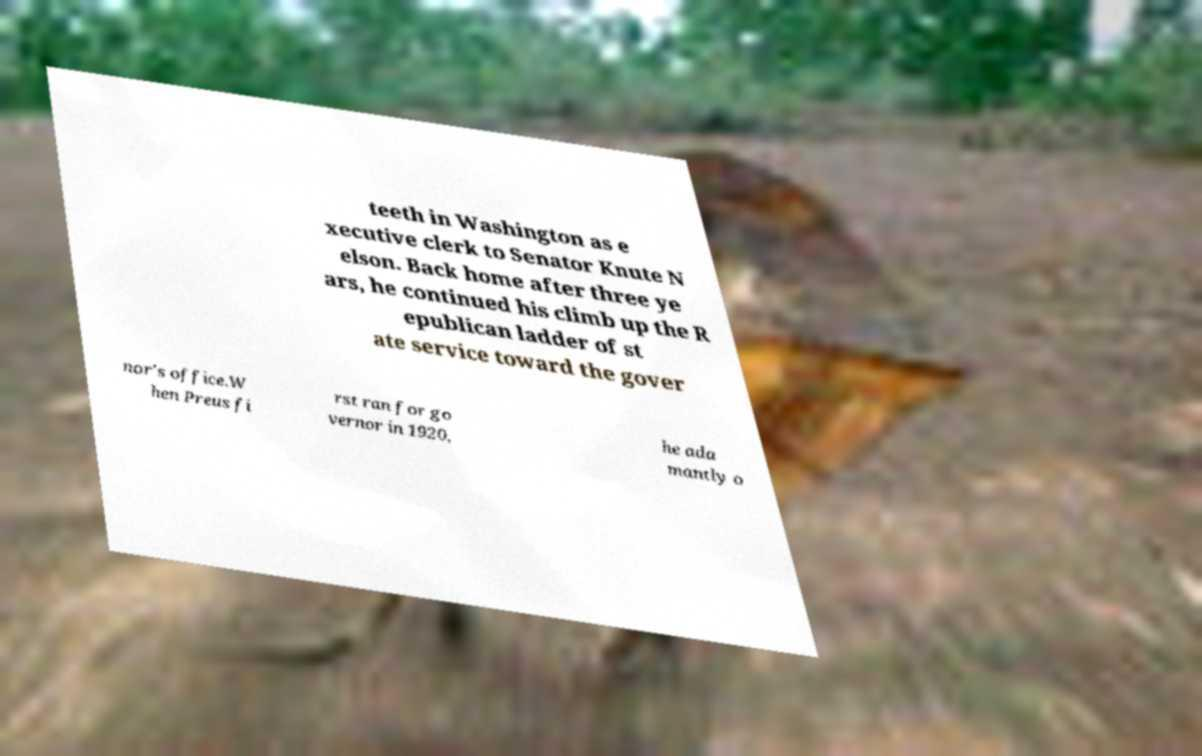For documentation purposes, I need the text within this image transcribed. Could you provide that? teeth in Washington as e xecutive clerk to Senator Knute N elson. Back home after three ye ars, he continued his climb up the R epublican ladder of st ate service toward the gover nor's office.W hen Preus fi rst ran for go vernor in 1920, he ada mantly o 